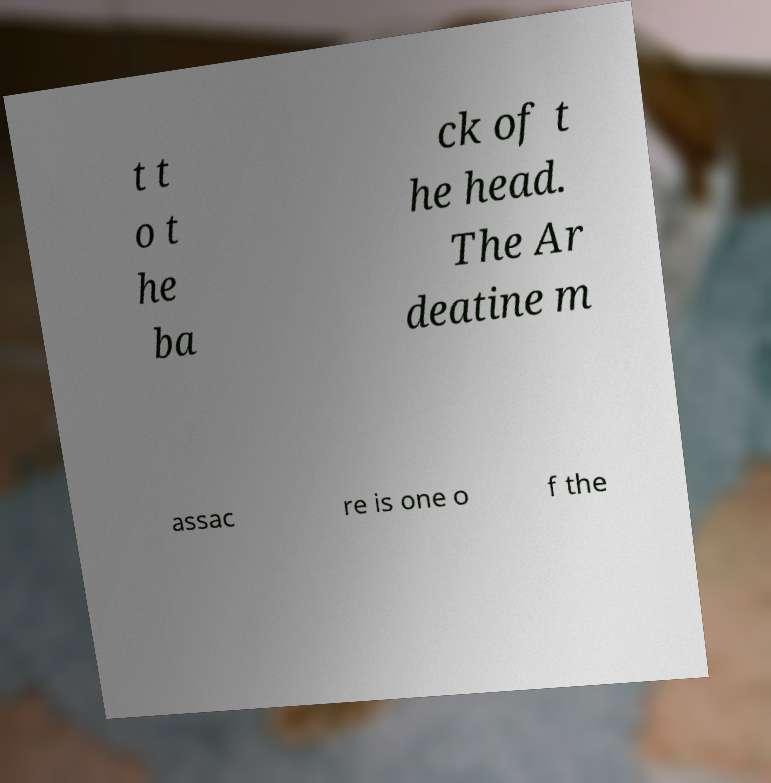Can you read and provide the text displayed in the image?This photo seems to have some interesting text. Can you extract and type it out for me? t t o t he ba ck of t he head. The Ar deatine m assac re is one o f the 